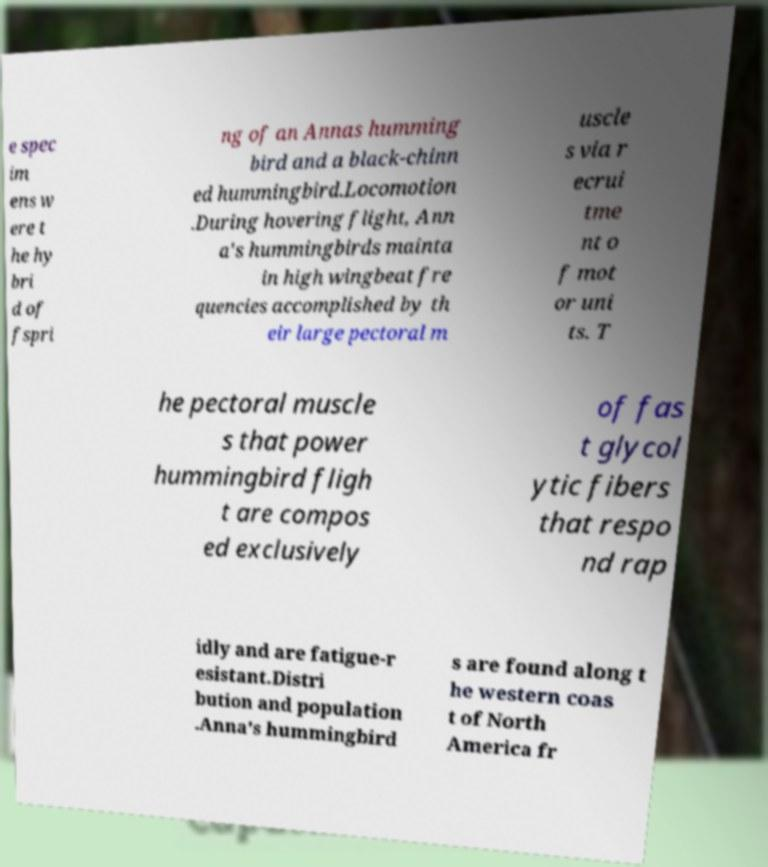Please read and relay the text visible in this image. What does it say? e spec im ens w ere t he hy bri d of fspri ng of an Annas humming bird and a black-chinn ed hummingbird.Locomotion .During hovering flight, Ann a's hummingbirds mainta in high wingbeat fre quencies accomplished by th eir large pectoral m uscle s via r ecrui tme nt o f mot or uni ts. T he pectoral muscle s that power hummingbird fligh t are compos ed exclusively of fas t glycol ytic fibers that respo nd rap idly and are fatigue-r esistant.Distri bution and population .Anna's hummingbird s are found along t he western coas t of North America fr 